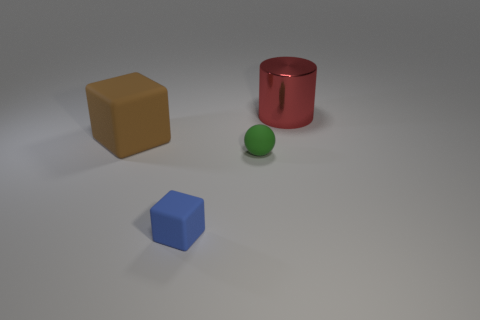Which of these objects is the largest? The red cylinder seems to be the largest object among the group when considering both its height and volume. 